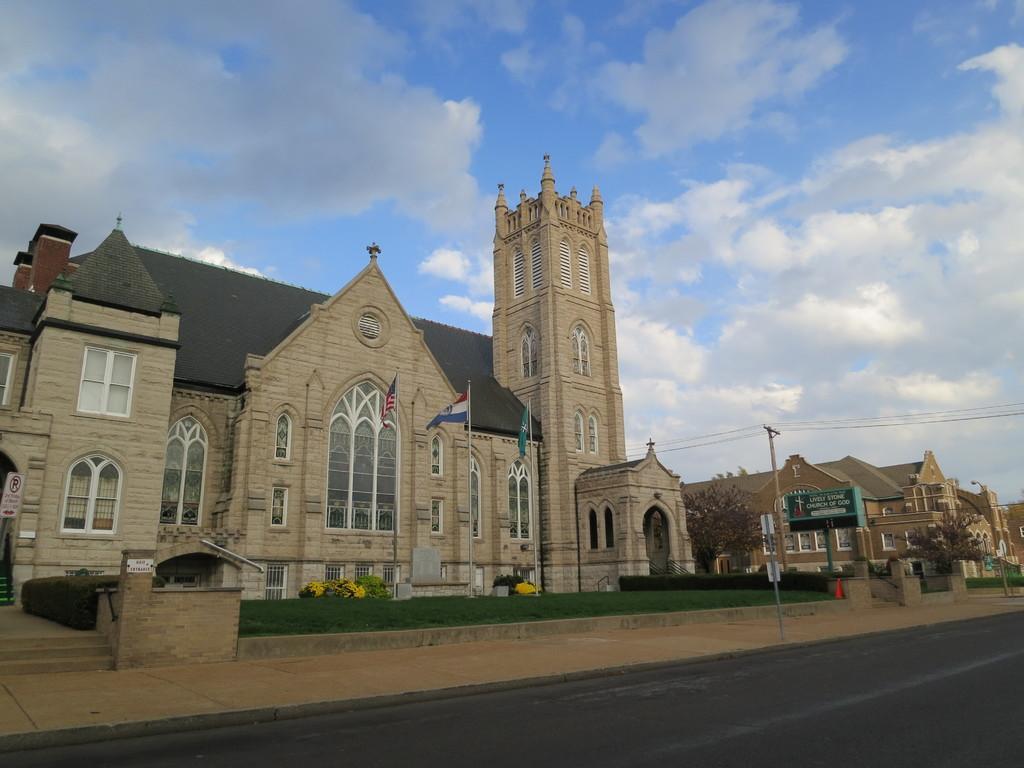In one or two sentences, can you explain what this image depicts? In the center of the image there are buildings, flags. At the top of the image there is sky. At the bottom of the image there is road. 